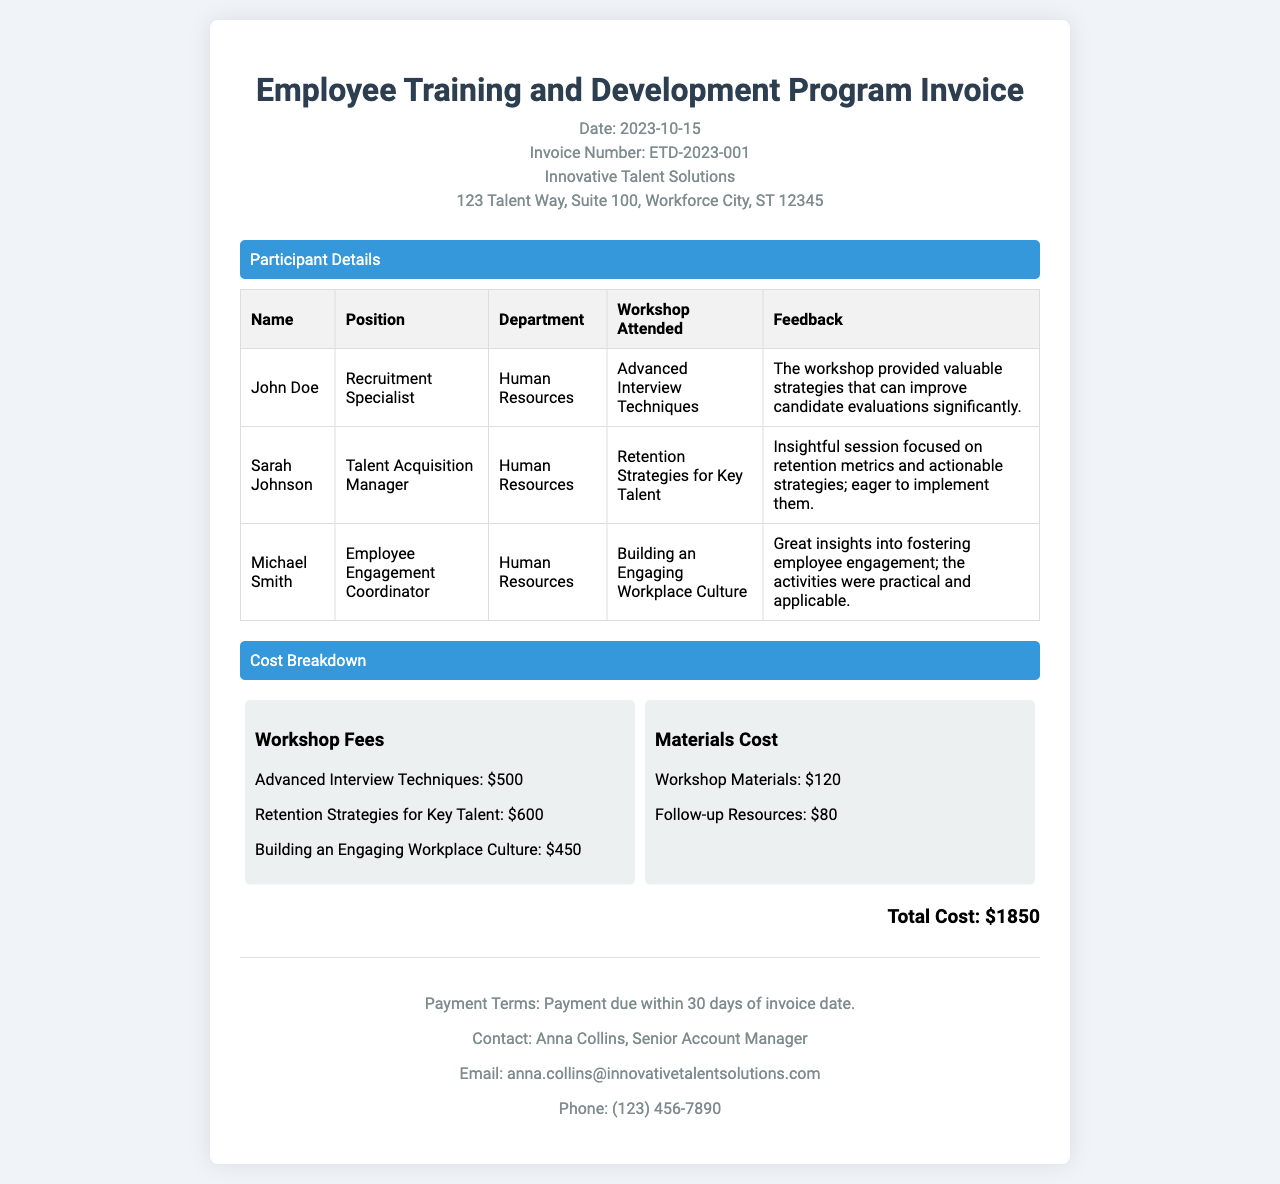What is the date of the invoice? The date of the invoice is mentioned in the header section.
Answer: 2023-10-15 Who is the contact person for this invoice? The contact person is listed in the footer section of the document.
Answer: Anna Collins How many workshops did John Doe attend? The participant details table lists workshops attended by each participant.
Answer: 1 What was the cost of the workshop on "Retention Strategies for Key Talent"? The cost breakdown section specifies workshop fees for each workshop.
Answer: $600 What was the total cost of the training program? The total cost is calculated from the individual costs listed in the cost breakdown.
Answer: $1850 Which department does Sarah Johnson work in? Sarah Johnson's details are listed in the participant details table.
Answer: Human Resources What feedback did Michael Smith provide? The feedback for each participant is found in the participant details table.
Answer: Great insights into fostering employee engagement; the activities were practical and applicable How many days do you have to report payment? The payment terms are detailed in the footer of the invoice.
Answer: 30 days What is the address of Innovative Talent Solutions? The address is located in the header section of the invoice.
Answer: 123 Talent Way, Suite 100, Workforce City, ST 12345 